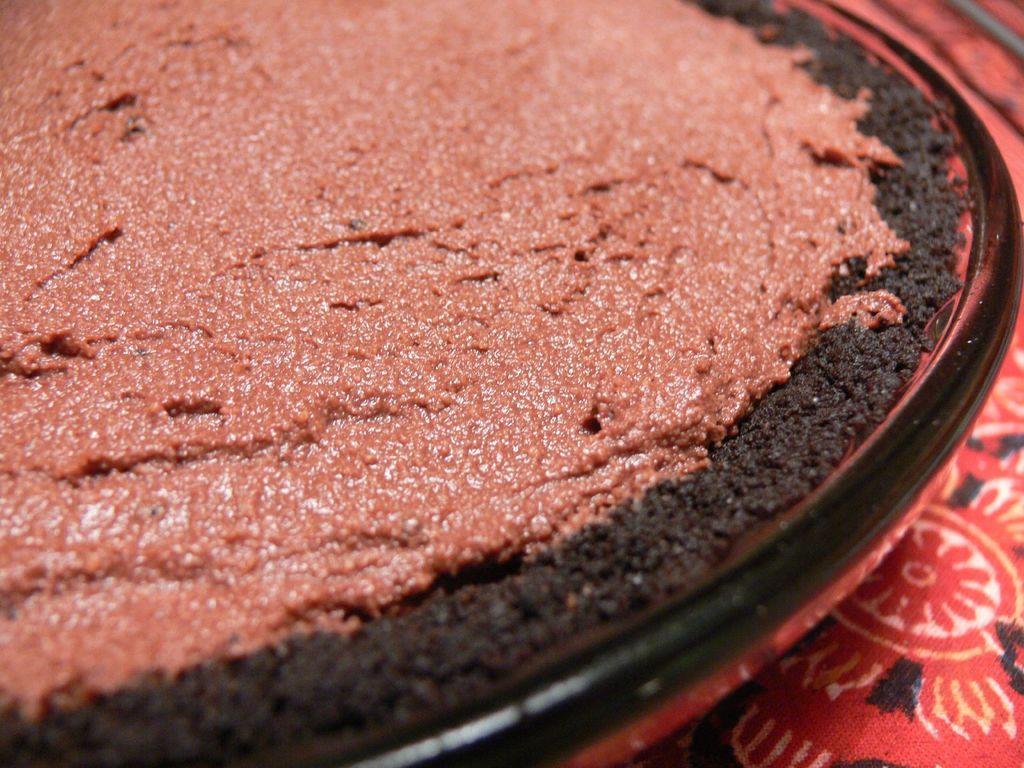Can you describe this image briefly? This picture shows some food in the plate and we see a cloth. 